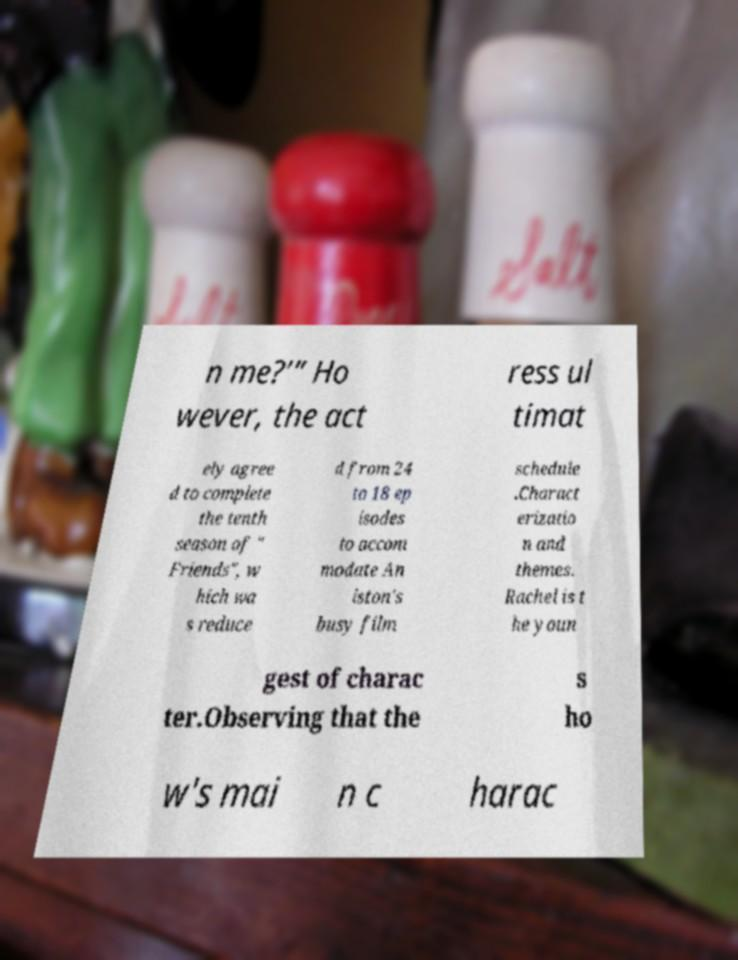Please read and relay the text visible in this image. What does it say? n me?’” Ho wever, the act ress ul timat ely agree d to complete the tenth season of " Friends", w hich wa s reduce d from 24 to 18 ep isodes to accom modate An iston's busy film schedule .Charact erizatio n and themes. Rachel is t he youn gest of charac ter.Observing that the s ho w's mai n c harac 